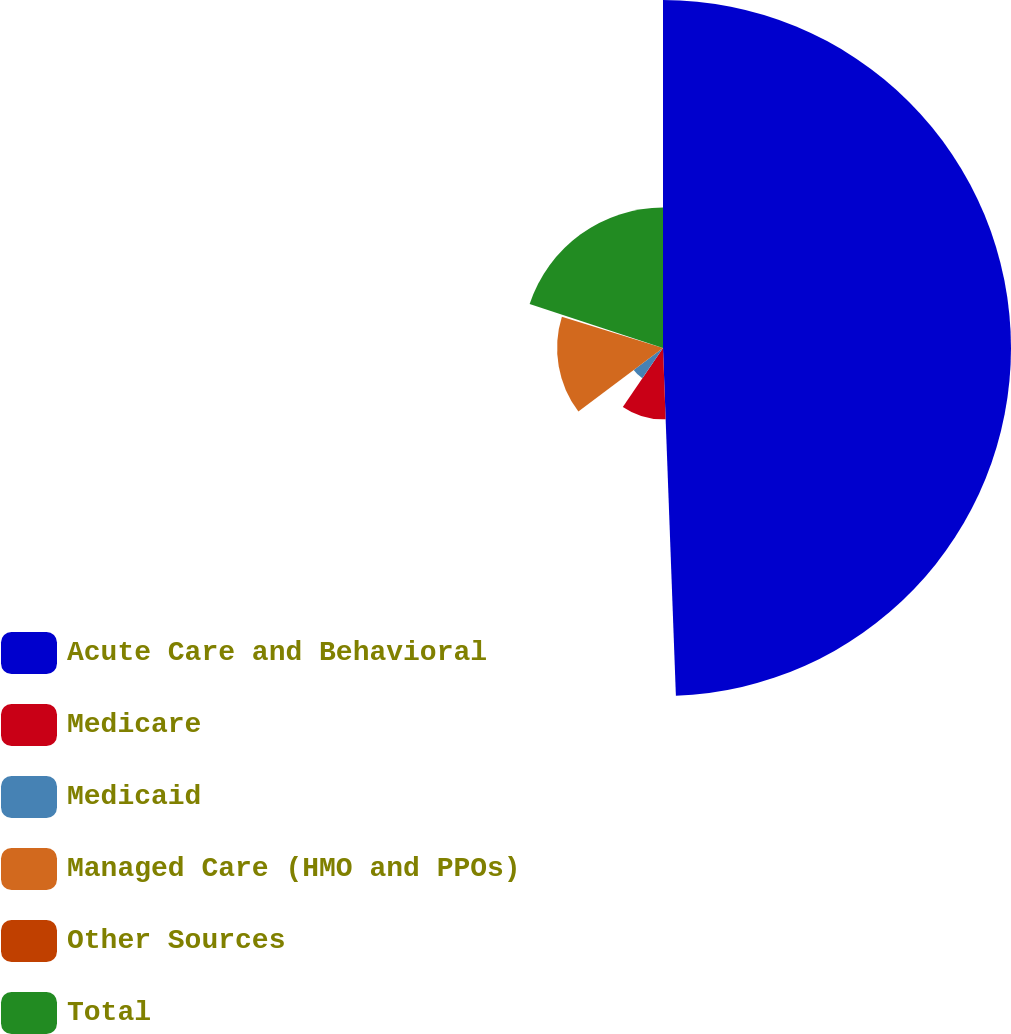<chart> <loc_0><loc_0><loc_500><loc_500><pie_chart><fcel>Acute Care and Behavioral<fcel>Medicare<fcel>Medicaid<fcel>Managed Care (HMO and PPOs)<fcel>Other Sources<fcel>Total<nl><fcel>49.41%<fcel>10.12%<fcel>5.21%<fcel>15.03%<fcel>0.29%<fcel>19.94%<nl></chart> 